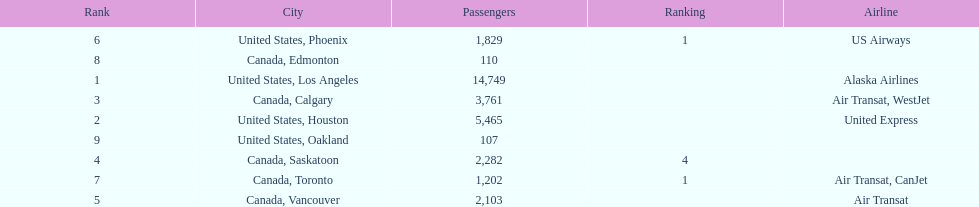The difference in passengers between los angeles and toronto 13,547. 